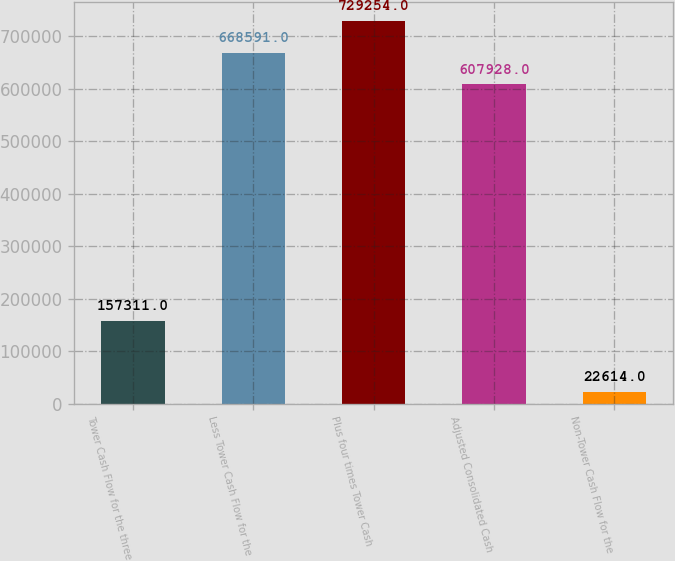<chart> <loc_0><loc_0><loc_500><loc_500><bar_chart><fcel>Tower Cash Flow for the three<fcel>Less Tower Cash Flow for the<fcel>Plus four times Tower Cash<fcel>Adjusted Consolidated Cash<fcel>Non-Tower Cash Flow for the<nl><fcel>157311<fcel>668591<fcel>729254<fcel>607928<fcel>22614<nl></chart> 